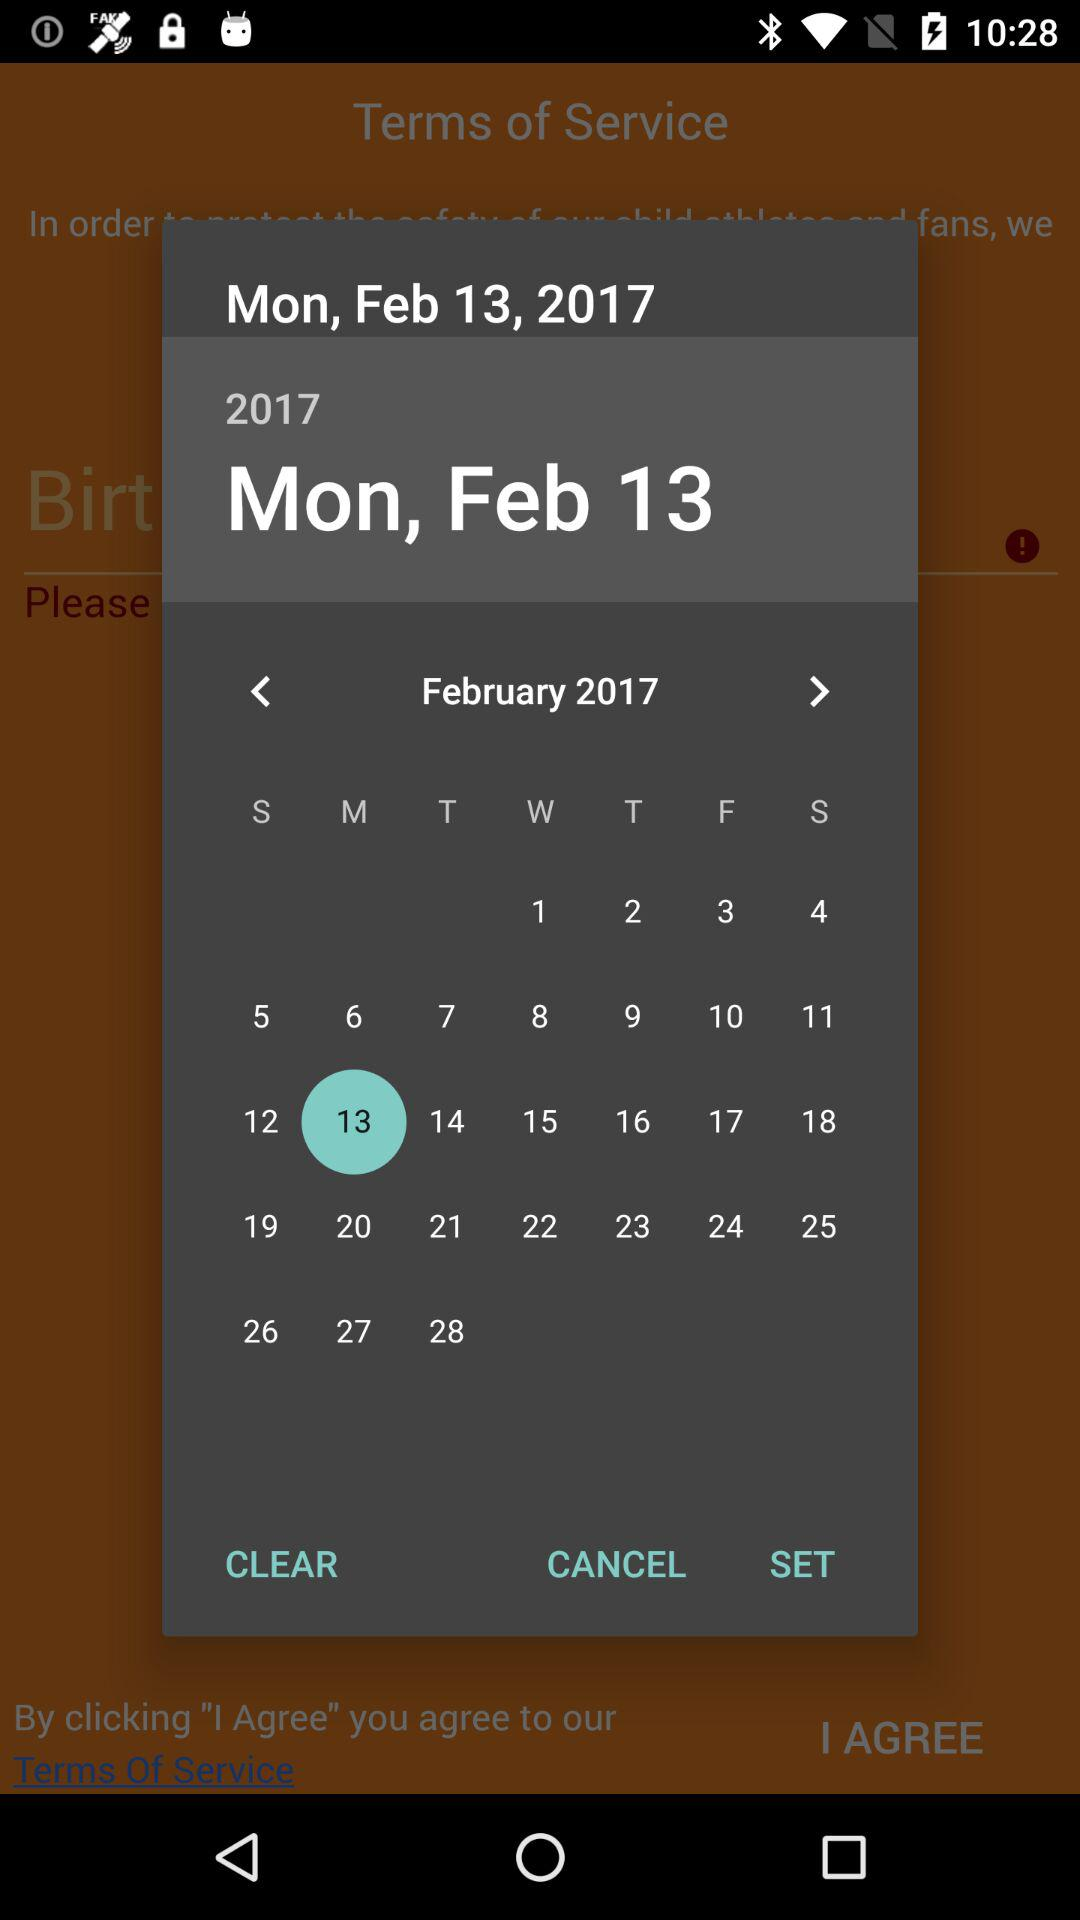Which month has been selected? The selected month is February. 